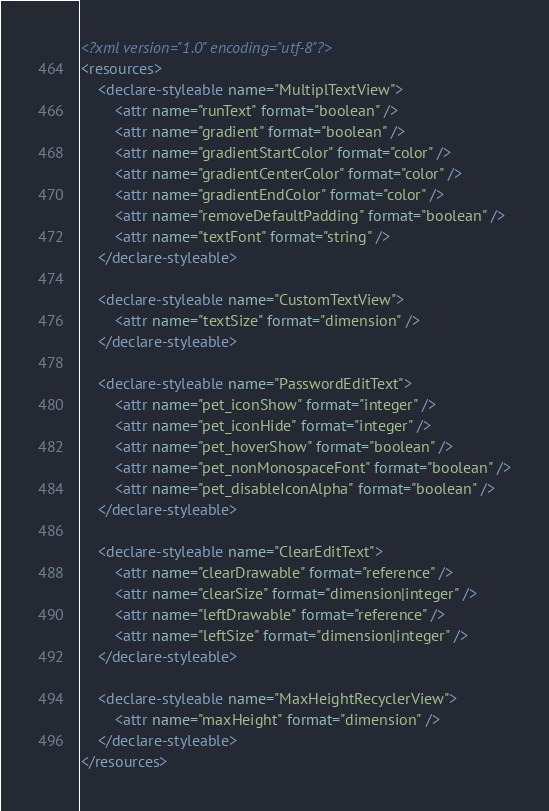Convert code to text. <code><loc_0><loc_0><loc_500><loc_500><_XML_><?xml version="1.0" encoding="utf-8"?>
<resources>
    <declare-styleable name="MultiplTextView">
        <attr name="runText" format="boolean" />
        <attr name="gradient" format="boolean" />
        <attr name="gradientStartColor" format="color" />
        <attr name="gradientCenterColor" format="color" />
        <attr name="gradientEndColor" format="color" />
        <attr name="removeDefaultPadding" format="boolean" />
        <attr name="textFont" format="string" />
    </declare-styleable>

    <declare-styleable name="CustomTextView">
        <attr name="textSize" format="dimension" />
    </declare-styleable>

    <declare-styleable name="PasswordEditText">
        <attr name="pet_iconShow" format="integer" />
        <attr name="pet_iconHide" format="integer" />
        <attr name="pet_hoverShow" format="boolean" />
        <attr name="pet_nonMonospaceFont" format="boolean" />
        <attr name="pet_disableIconAlpha" format="boolean" />
    </declare-styleable>

    <declare-styleable name="ClearEditText">
        <attr name="clearDrawable" format="reference" />
        <attr name="clearSize" format="dimension|integer" />
        <attr name="leftDrawable" format="reference" />
        <attr name="leftSize" format="dimension|integer" />
    </declare-styleable>

    <declare-styleable name="MaxHeightRecyclerView">
        <attr name="maxHeight" format="dimension" />
    </declare-styleable>
</resources>
</code> 